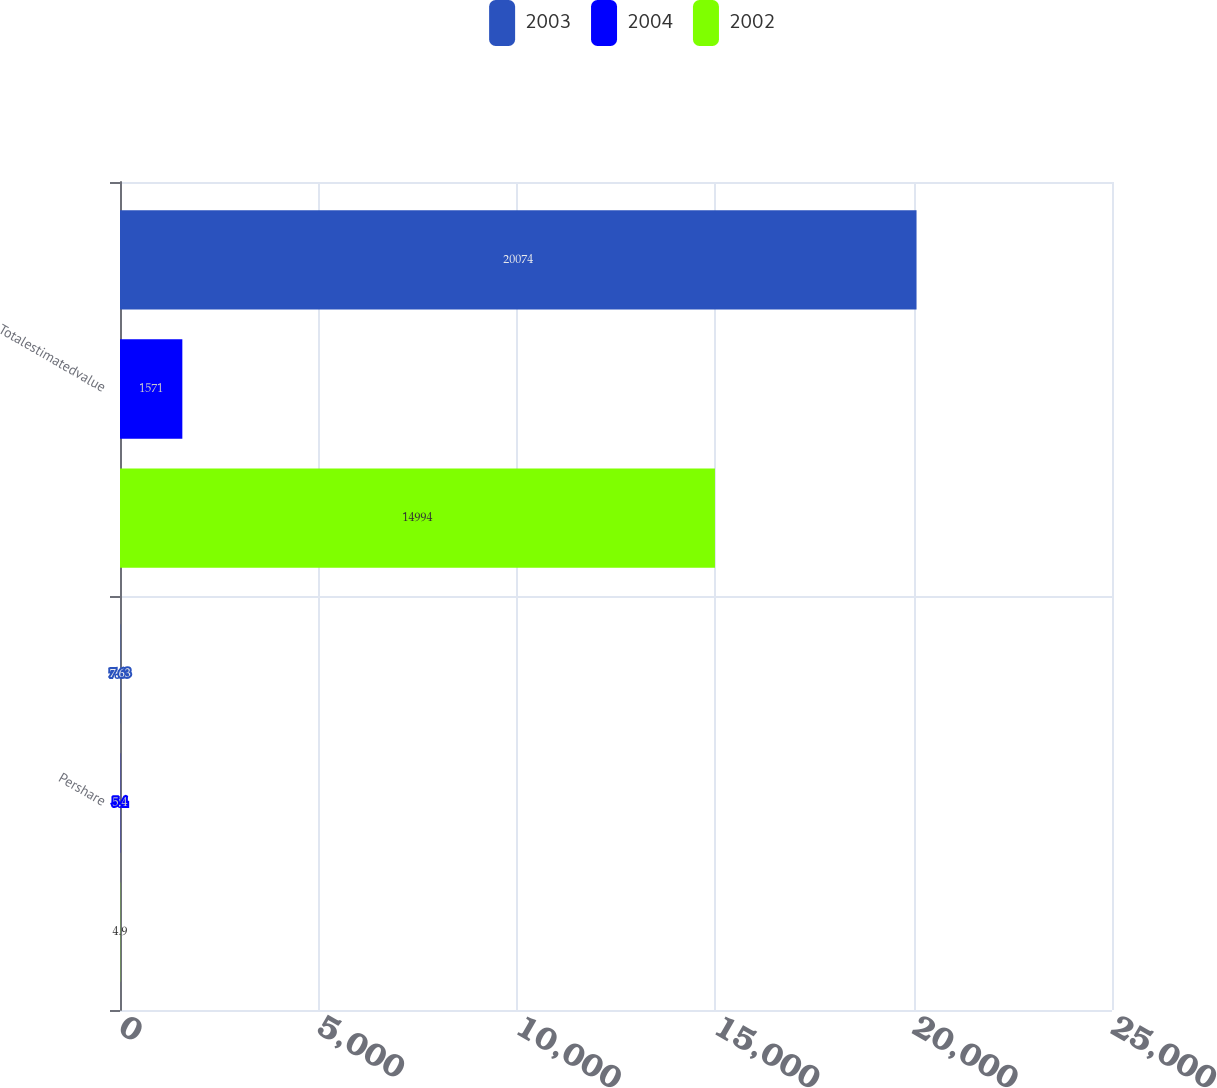Convert chart to OTSL. <chart><loc_0><loc_0><loc_500><loc_500><stacked_bar_chart><ecel><fcel>Pershare<fcel>Totalestimatedvalue<nl><fcel>2003<fcel>7.63<fcel>20074<nl><fcel>2004<fcel>5.4<fcel>1571<nl><fcel>2002<fcel>4.9<fcel>14994<nl></chart> 